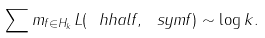Convert formula to latex. <formula><loc_0><loc_0><loc_500><loc_500>\sum m _ { f \in H _ { k } } L ( \ h h a l f , \ s y m f ) \sim \log k .</formula> 